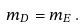Convert formula to latex. <formula><loc_0><loc_0><loc_500><loc_500>m _ { D } = m _ { E } \, .</formula> 